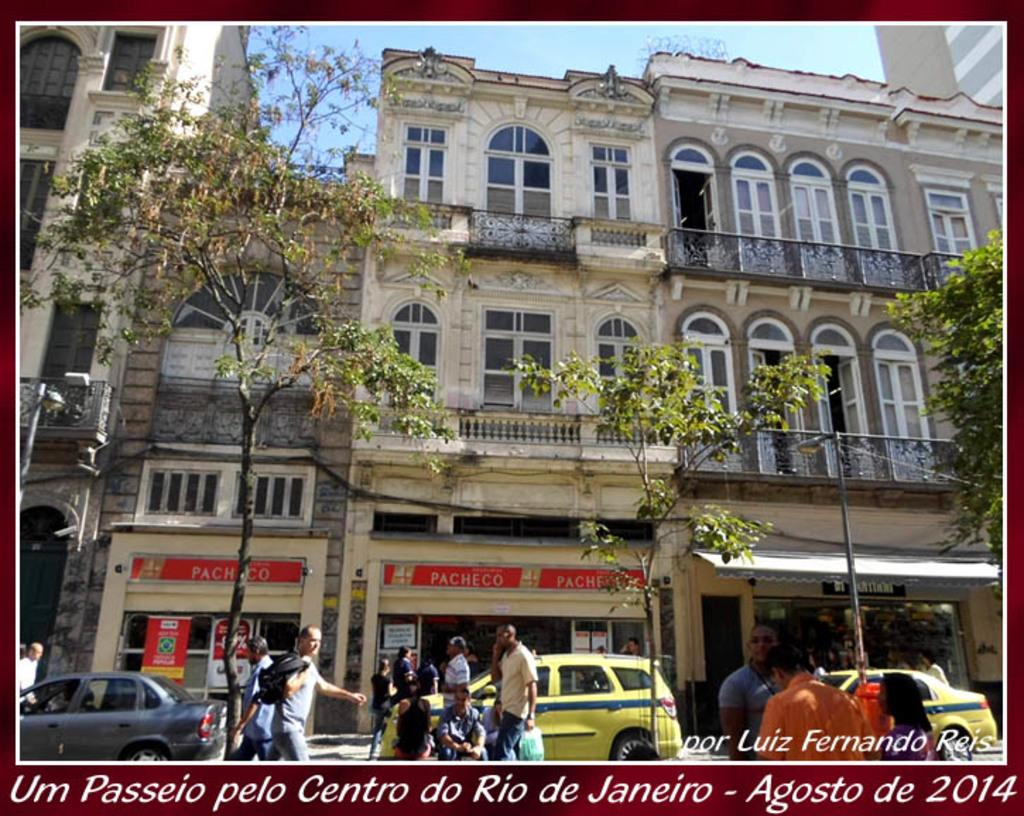<image>
Summarize the visual content of the image. the word Passeio that is on a caption 